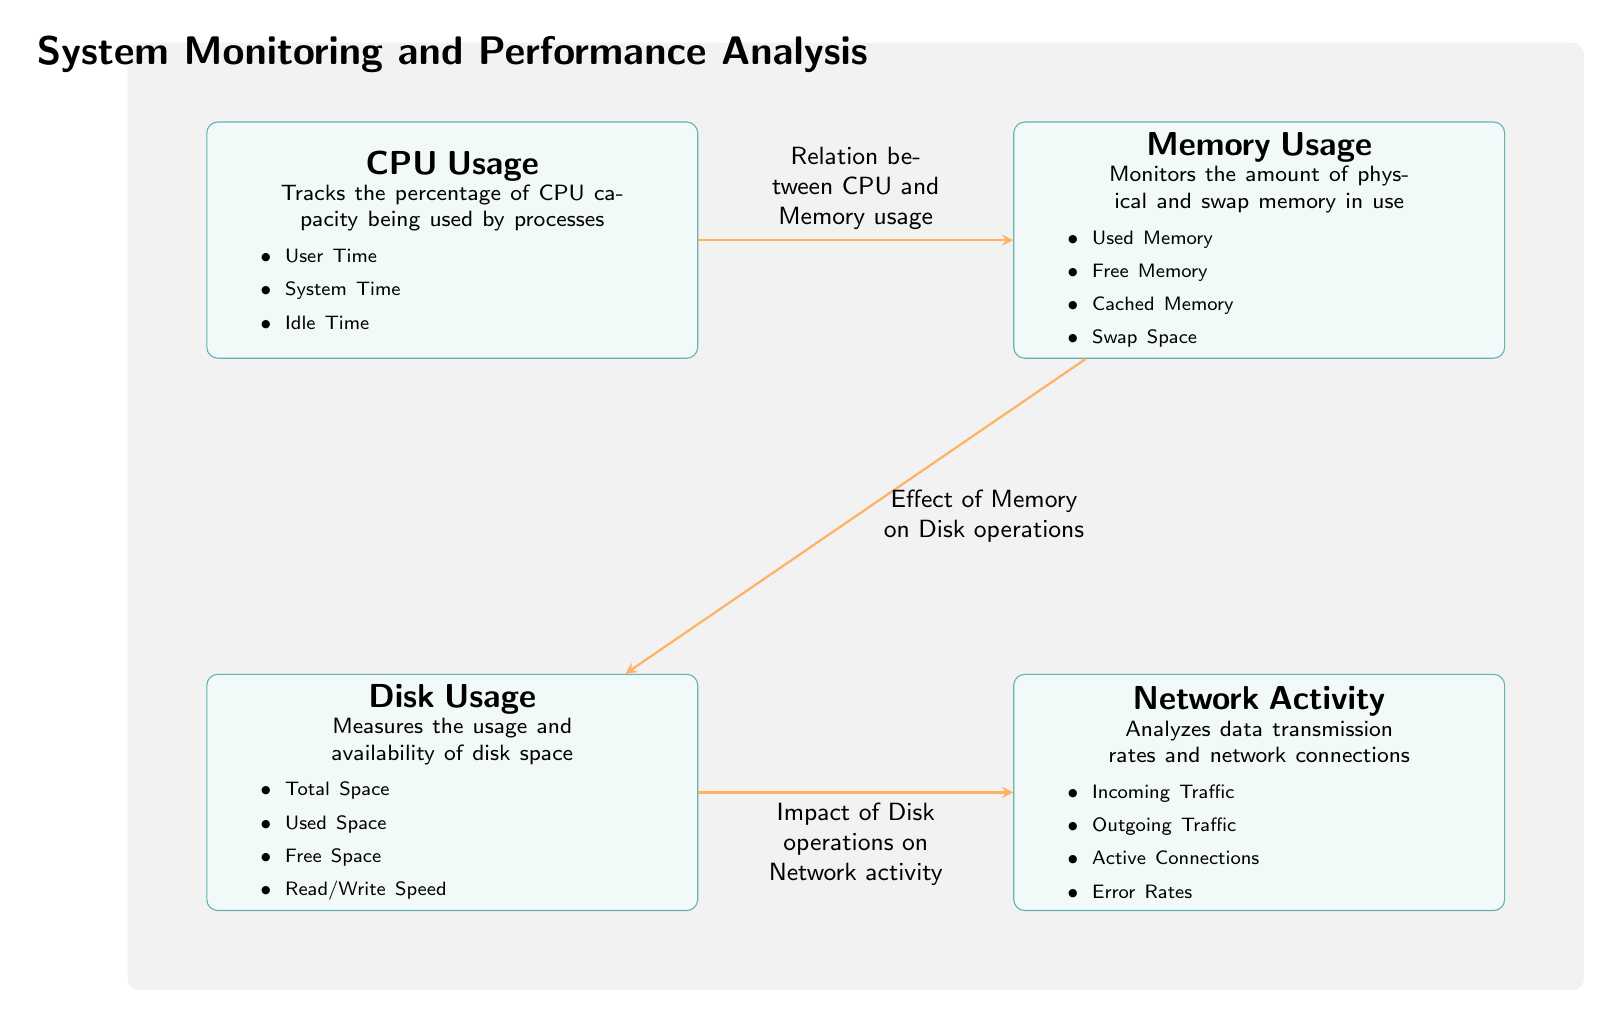What are the four main components monitored in this diagram? The diagram clearly lists four main components which include CPU Usage, Memory Usage, Disk Usage, and Network Activity.
Answer: CPU Usage, Memory Usage, Disk Usage, Network Activity What type of relationship exists between CPU and Memory Usage nodes? The diagram indicates a relation described as "Relation between CPU and Memory usage" connecting the CPU Usage node to the Memory Usage node.
Answer: Relation between CPU and Memory usage How many nodes represent usage metrics in the diagram? There are four distinct nodes that represent usage metrics: CPU Usage, Memory Usage, Disk Usage, and Network Activity, totaling four nodes.
Answer: Four nodes What is monitored under Memory Usage? The Memory Usage node describes monitoring Used Memory, Free Memory, Cached Memory, and Swap Space.
Answer: Used Memory, Free Memory, Cached Memory, Swap Space What effect does Memory have according to this diagram? The diagram states "Effect of Memory on Disk operations," indicating that memory usage has a direct impact on disk operations.
Answer: Effect of Memory on Disk operations Which component is analyzed in relation to network activity? The diagram suggests that Disk Usage impacts Network Activity, as indicated by the line labeled "Impact of Disk operations on Network activity."
Answer: Disk Usage What details are tracked under CPU Usage based on the diagram? Under CPU Usage, it tracks User Time, System Time, and Idle Time according to the details listed in the node.
Answer: User Time, System Time, Idle Time How does the flow move from Disk Usage to Network Activity? The flow from Disk Usage to Network Activity is indicated by the arrow labeled "Impact of Disk operations on Network activity," showing the direct impact of disk usage on network performance.
Answer: Impact of Disk operations on Network activity 